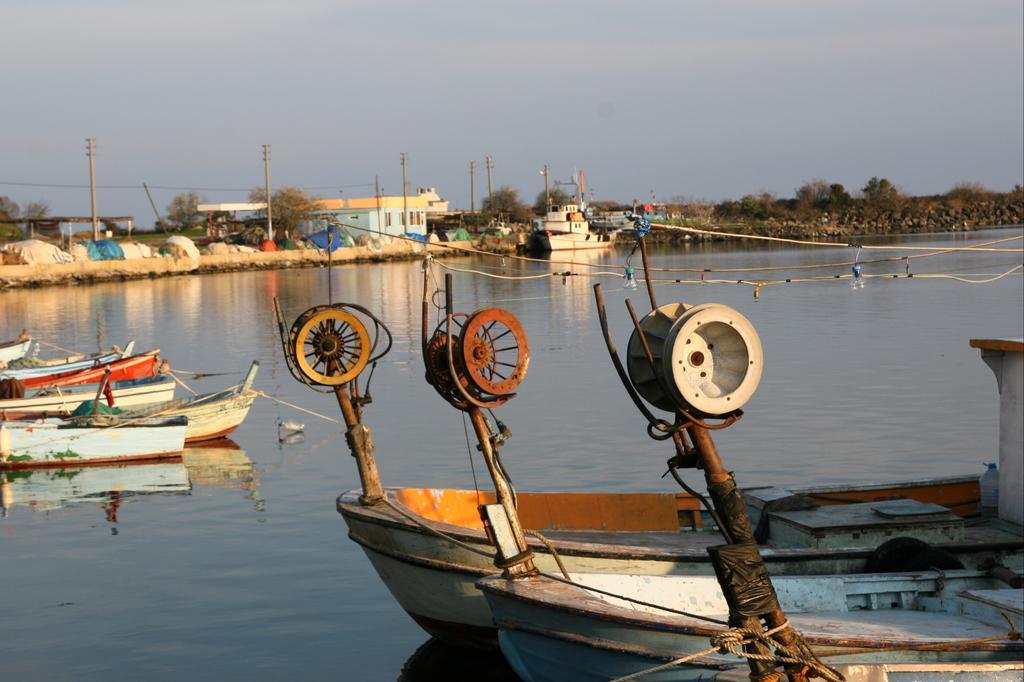Could you give a brief overview of what you see in this image? In front of the image there are engines on the boats, behind the engine there are a few other boats on the water, behind that there is a rope passing on top of the river and there is a ship on the river, on the other side of the river there are electrical poles with cables on it, tents with poles, covers, trees, houses and rocks. 